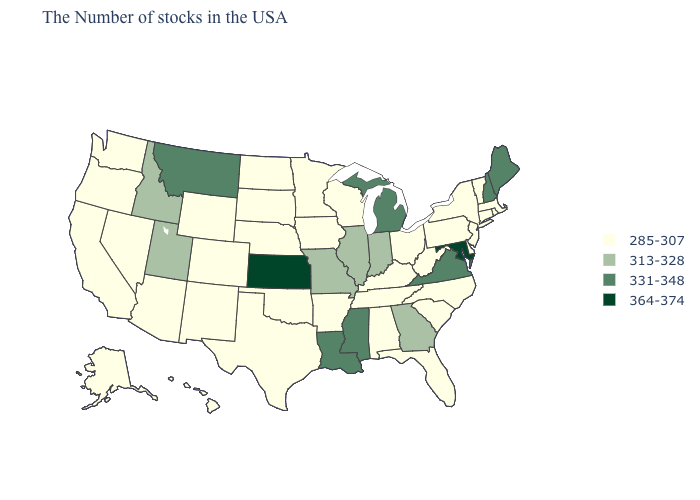What is the value of North Carolina?
Give a very brief answer. 285-307. Which states hav the highest value in the MidWest?
Write a very short answer. Kansas. Which states hav the highest value in the South?
Answer briefly. Maryland. Does Ohio have a lower value than Indiana?
Keep it brief. Yes. Name the states that have a value in the range 364-374?
Answer briefly. Maryland, Kansas. What is the highest value in states that border Wisconsin?
Answer briefly. 331-348. What is the value of Washington?
Keep it brief. 285-307. What is the value of Tennessee?
Give a very brief answer. 285-307. How many symbols are there in the legend?
Be succinct. 4. Does Massachusetts have the highest value in the Northeast?
Concise answer only. No. Which states have the highest value in the USA?
Be succinct. Maryland, Kansas. What is the value of Rhode Island?
Answer briefly. 285-307. Does Louisiana have the lowest value in the USA?
Keep it brief. No. What is the lowest value in states that border Maine?
Keep it brief. 331-348. 